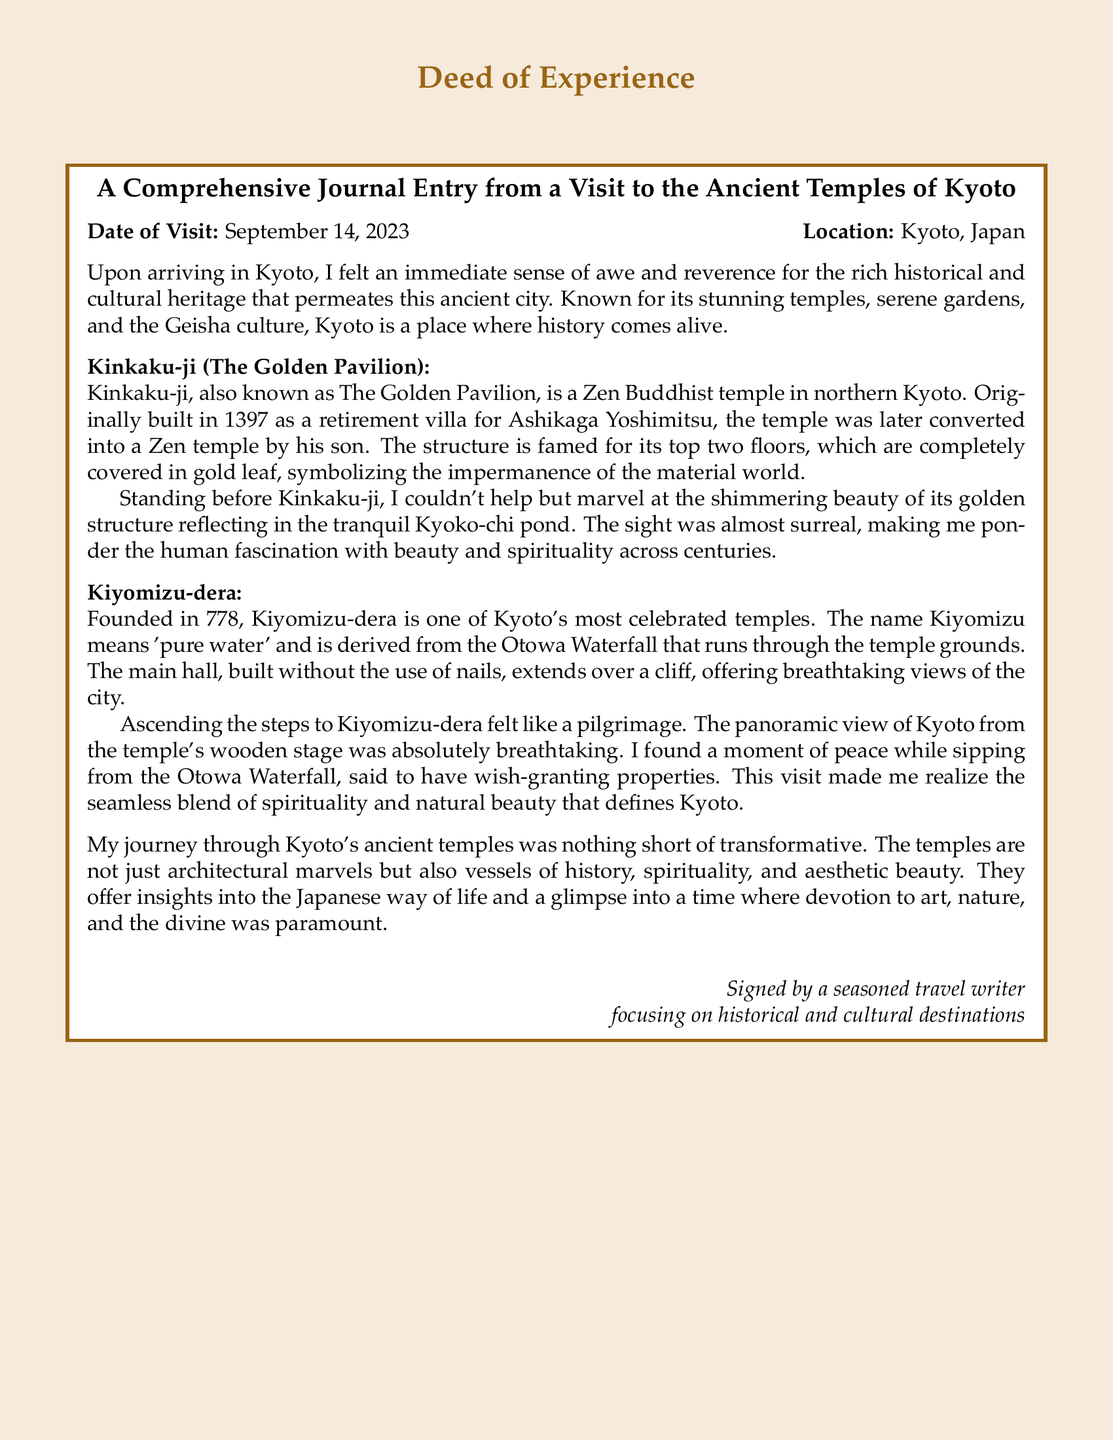What is the date of visit? The date of visit is mentioned at the beginning of the document.
Answer: September 14, 2023 What is the location of the visit? The location of the visit is stated alongside the date of visit.
Answer: Kyoto, Japan What is the name of the temple known as The Golden Pavilion? The document provides the name of the temple as part of its description.
Answer: Kinkaku-ji In what year was Kiyomizu-dera founded? The founding year of Kiyomizu-dera is specified in the journal entry.
Answer: 778 What does "Kiyomizu" mean? The meaning of Kiyomizu is explained in the document.
Answer: Pure water What architectural feature is notable about Kiyomizu-dera’s main hall? The document details a distinctive characteristic of the main hall.
Answer: Built without the use of nails What reflection did the author have while visiting Kinkaku-ji? The author’s personal reflection is described after visiting Kinkaku-ji.
Answer: Human fascination with beauty and spirituality What aspect of the visit made the author feel like it was a pilgrimage? A specific experience that contributed to the feeling of pilgrimage is mentioned in the journal.
Answer: Ascending the steps to Kiyomizu-dera What do the temples signify about Japanese culture according to the author? The author reflects on what the temples represent regarding Japanese life.
Answer: Vessels of history, spirituality, and aesthetic beauty 